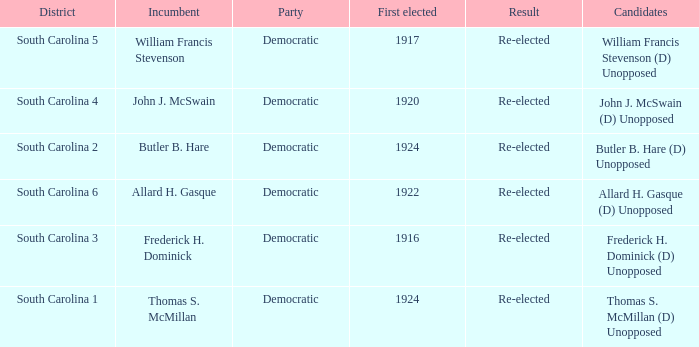What year was william francis stevenson first elected? 1917.0. Could you parse the entire table? {'header': ['District', 'Incumbent', 'Party', 'First elected', 'Result', 'Candidates'], 'rows': [['South Carolina 5', 'William Francis Stevenson', 'Democratic', '1917', 'Re-elected', 'William Francis Stevenson (D) Unopposed'], ['South Carolina 4', 'John J. McSwain', 'Democratic', '1920', 'Re-elected', 'John J. McSwain (D) Unopposed'], ['South Carolina 2', 'Butler B. Hare', 'Democratic', '1924', 'Re-elected', 'Butler B. Hare (D) Unopposed'], ['South Carolina 6', 'Allard H. Gasque', 'Democratic', '1922', 'Re-elected', 'Allard H. Gasque (D) Unopposed'], ['South Carolina 3', 'Frederick H. Dominick', 'Democratic', '1916', 'Re-elected', 'Frederick H. Dominick (D) Unopposed'], ['South Carolina 1', 'Thomas S. McMillan', 'Democratic', '1924', 'Re-elected', 'Thomas S. McMillan (D) Unopposed']]} 